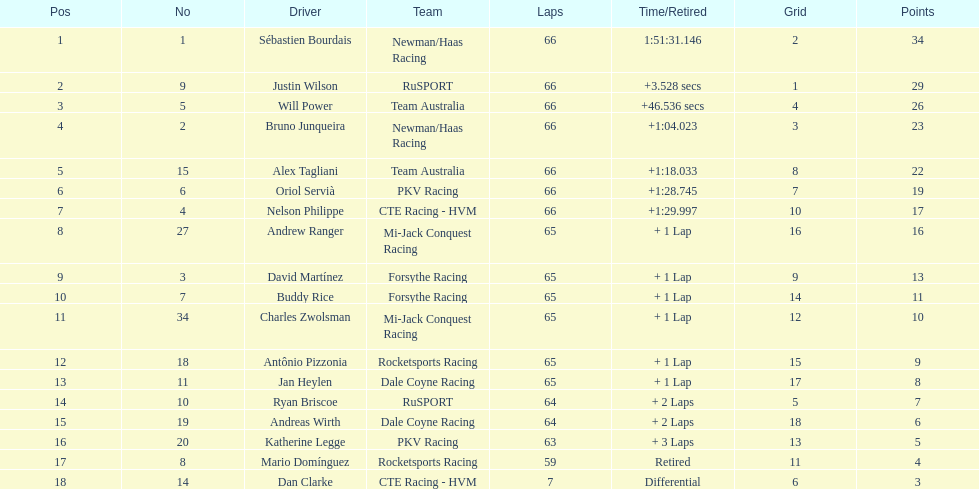How many drivers failed to exceed 60 laps? 2. 